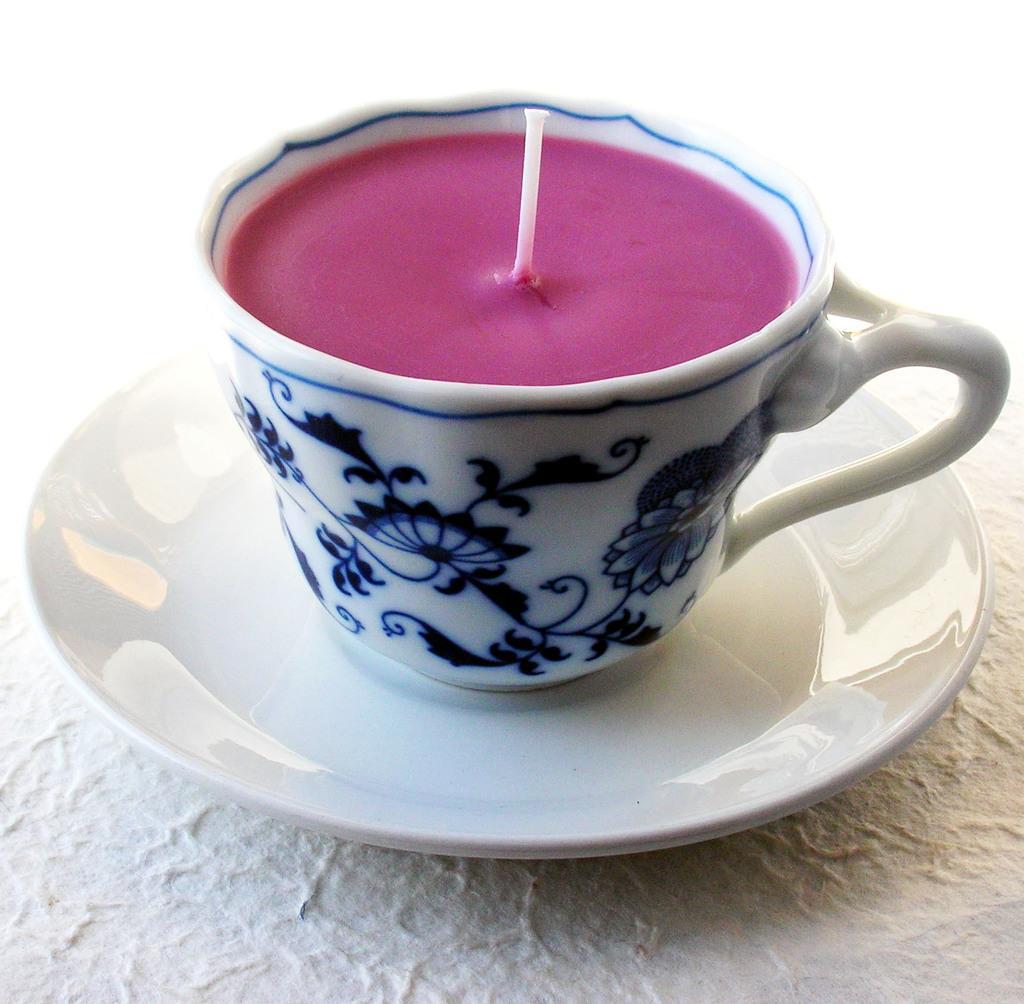Can you describe this image briefly? In this image we can see a cup placed on a saucer containing wax and a thread are kept on the surface. 